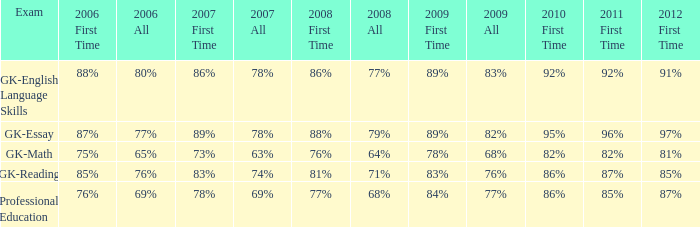What is the percentage for first time 2011 when the first time in 2009 is 68%? 82%. 